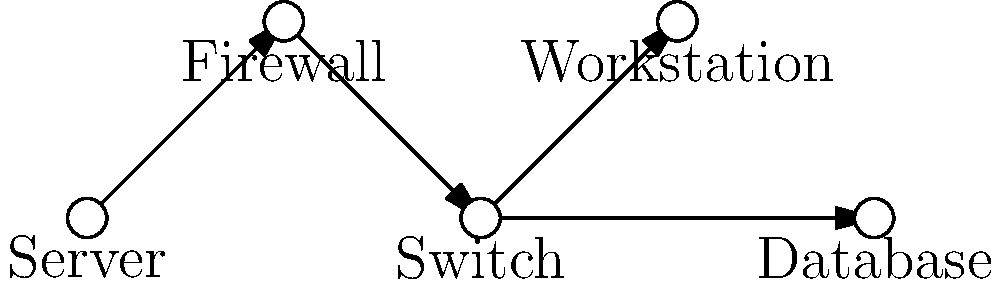In the network topology diagram above, which component represents the most critical point of vulnerability that could potentially expose sensitive information if compromised? To identify the most critical point of vulnerability in this network topology, we need to consider the role and position of each component:

1. Server: Stores and processes data, but is protected by the firewall.
2. Firewall: Acts as a barrier between the internal network and external threats.
3. Switch: Connects various network components but doesn't typically store sensitive data.
4. Workstation: End-user device that accesses network resources.
5. Database: Stores large amounts of potentially sensitive information.

The most critical point of vulnerability in this diagram is the database for the following reasons:

1. Direct connection: The database is directly connected to the switch without an additional layer of security.
2. Sensitive data storage: Databases typically contain large amounts of sensitive information, making them attractive targets for cybercriminals.
3. Potential for data exfiltration: If compromised, the database could allow for the extraction of vast amounts of sensitive data.
4. Lack of firewall protection: Unlike the server, the database is not directly protected by the firewall, increasing its exposure to potential attacks.

While other components are also important, the database represents the most significant risk due to its content and position in the network topology.
Answer: Database 